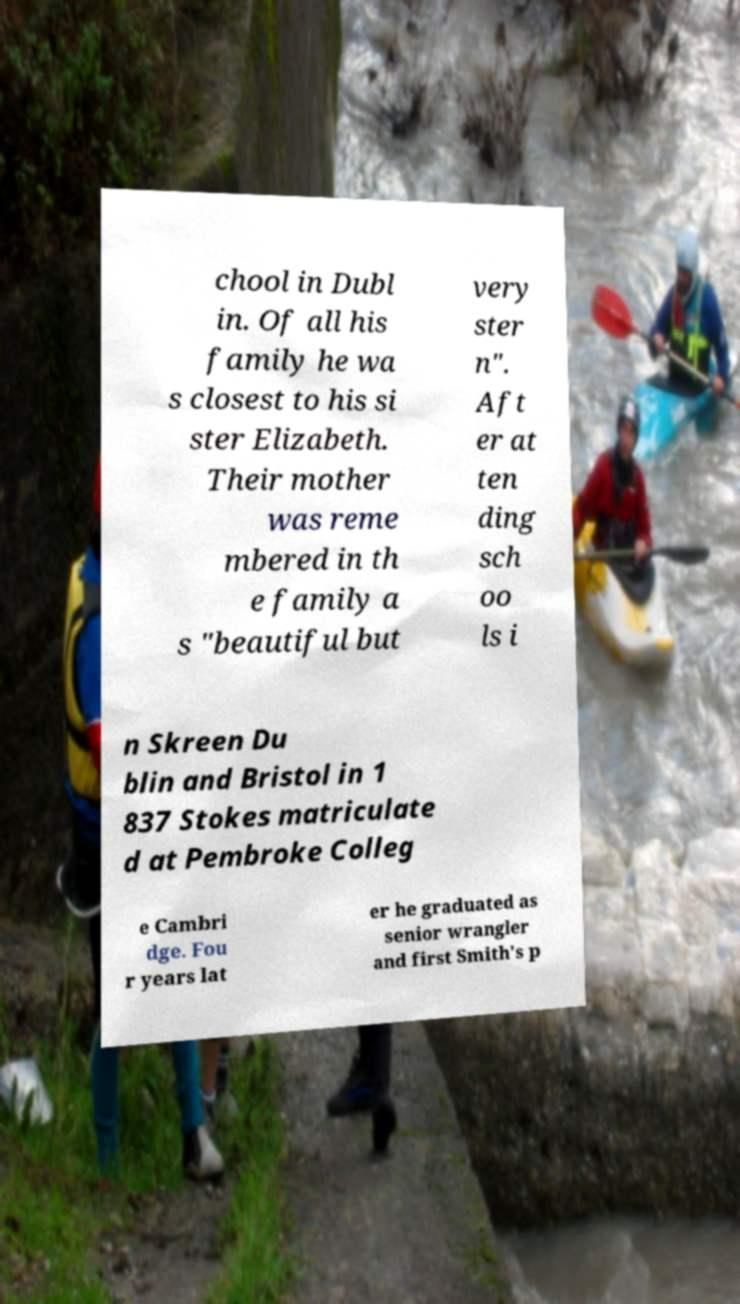For documentation purposes, I need the text within this image transcribed. Could you provide that? chool in Dubl in. Of all his family he wa s closest to his si ster Elizabeth. Their mother was reme mbered in th e family a s "beautiful but very ster n". Aft er at ten ding sch oo ls i n Skreen Du blin and Bristol in 1 837 Stokes matriculate d at Pembroke Colleg e Cambri dge. Fou r years lat er he graduated as senior wrangler and first Smith's p 